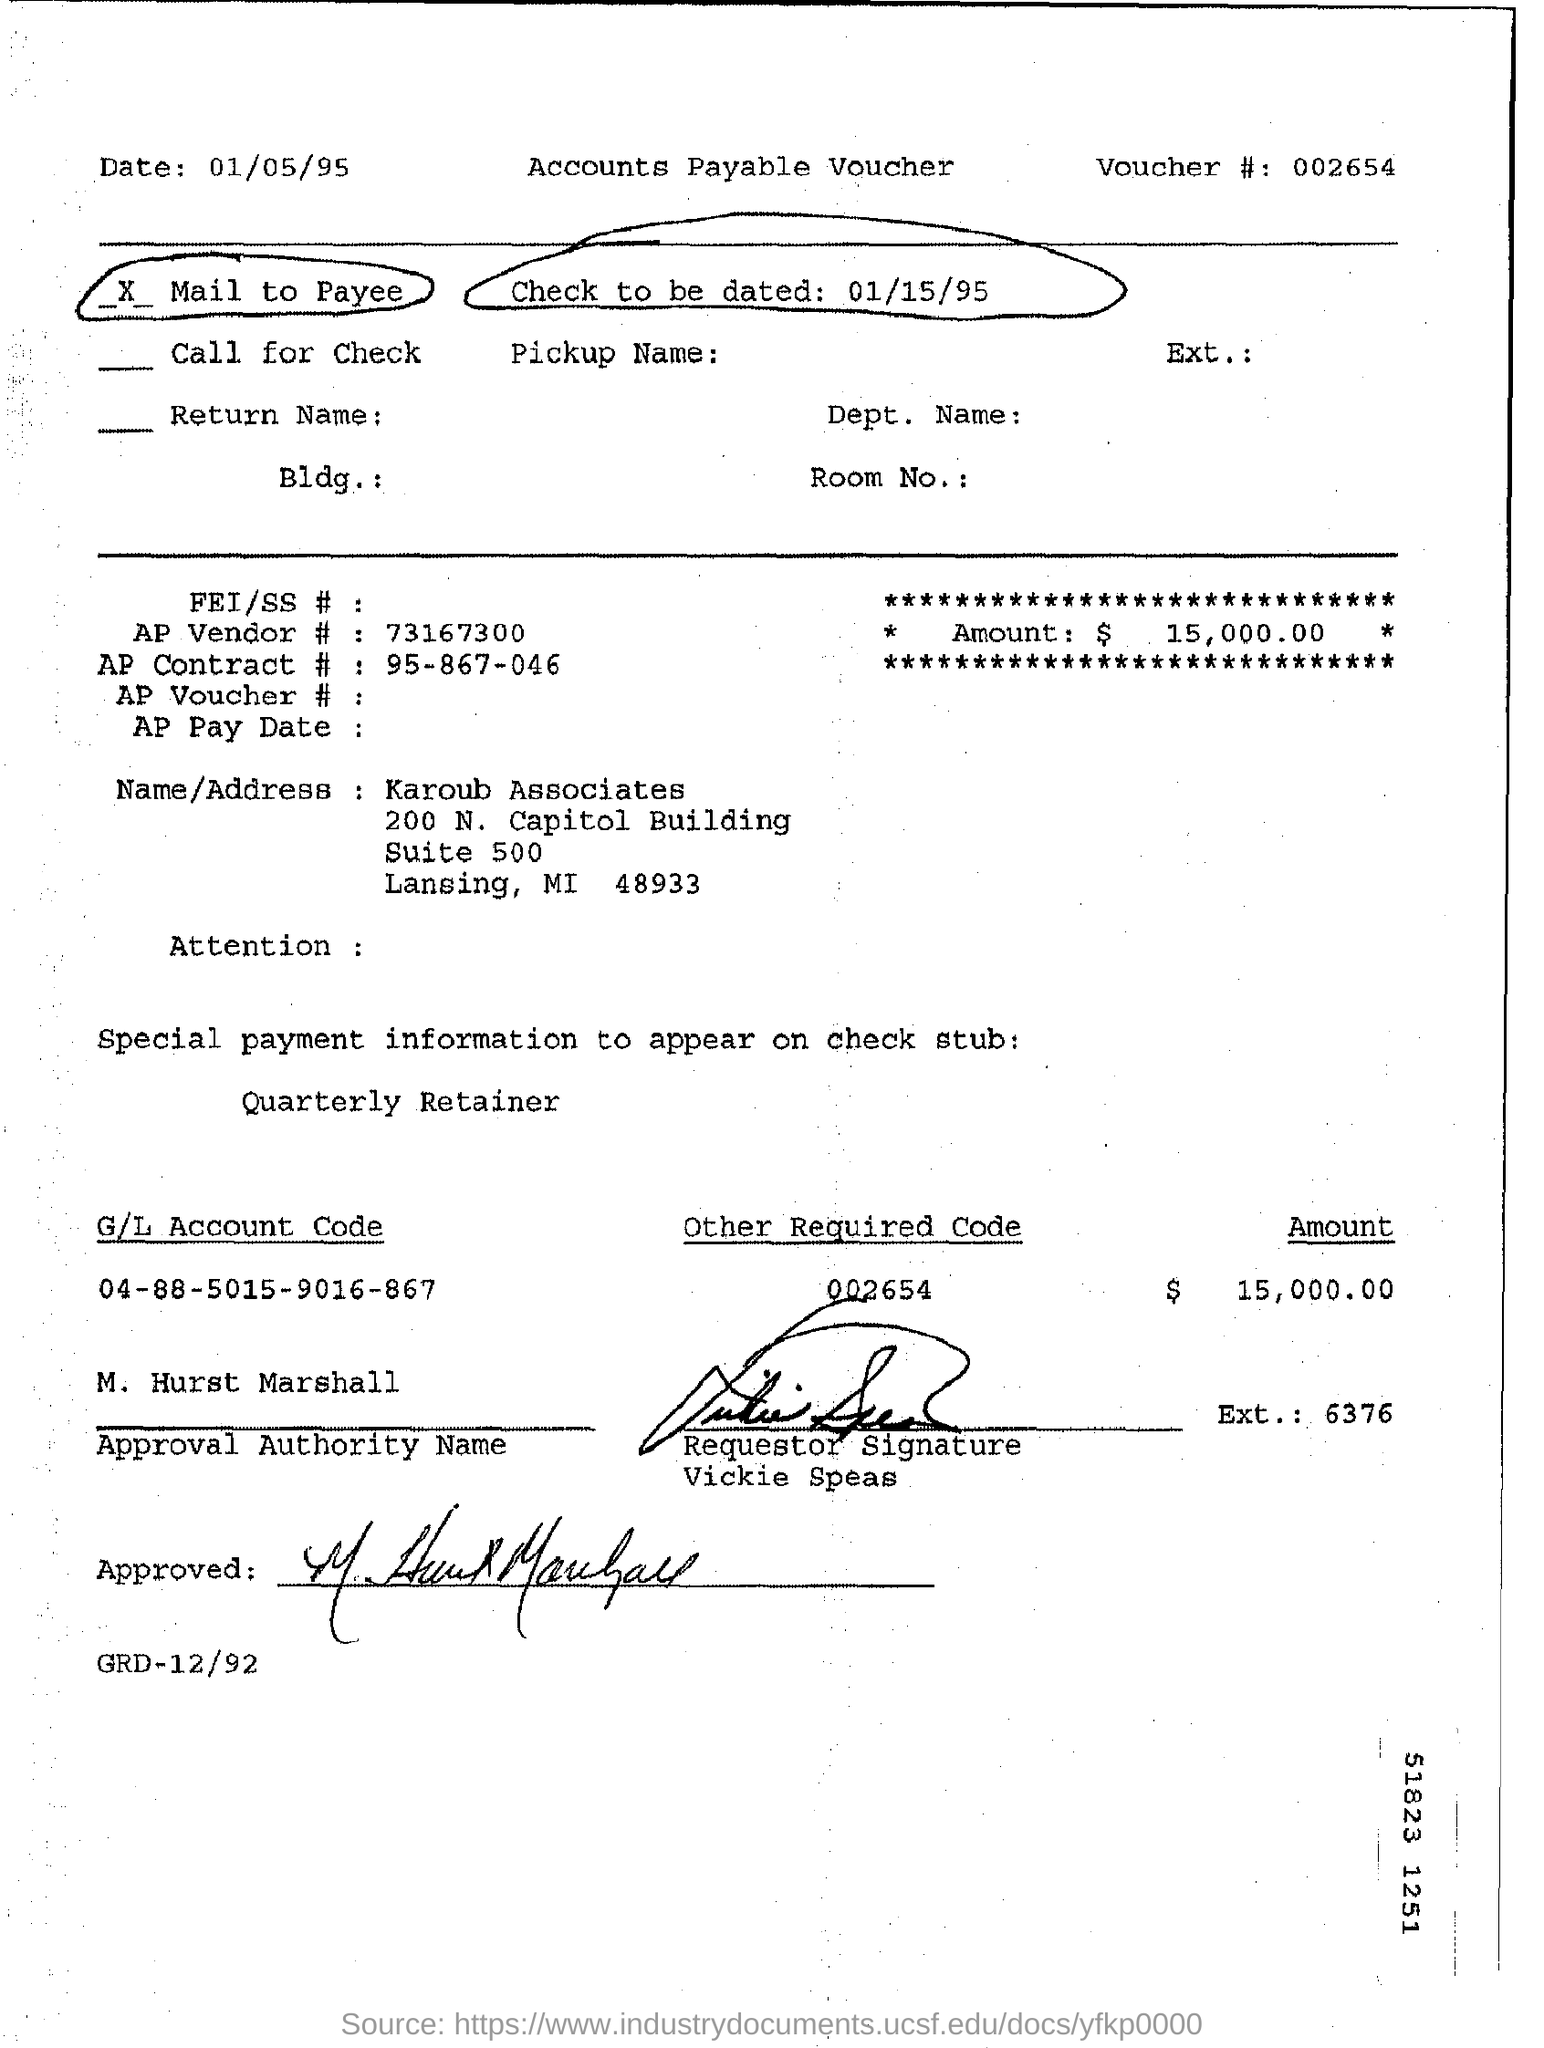When is the check to be dated?
Ensure brevity in your answer.  01/15/95. What is the voucher number?
Make the answer very short. 002654. What is the amount specified?
Ensure brevity in your answer.  $15,000.00. What is the G/L Account Code mentioned?
Ensure brevity in your answer.  04-88-5015-9016-867. 